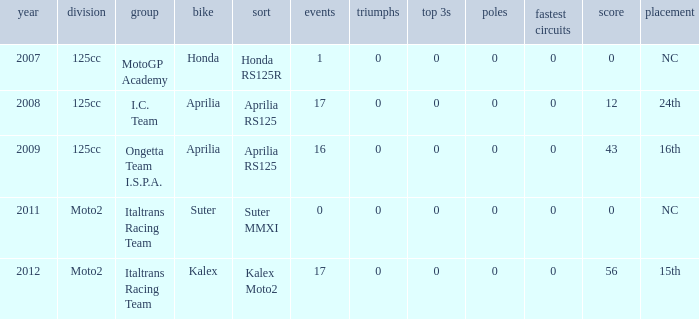What's the number of poles in the season where the team had a Kalex motorcycle? 0.0. 